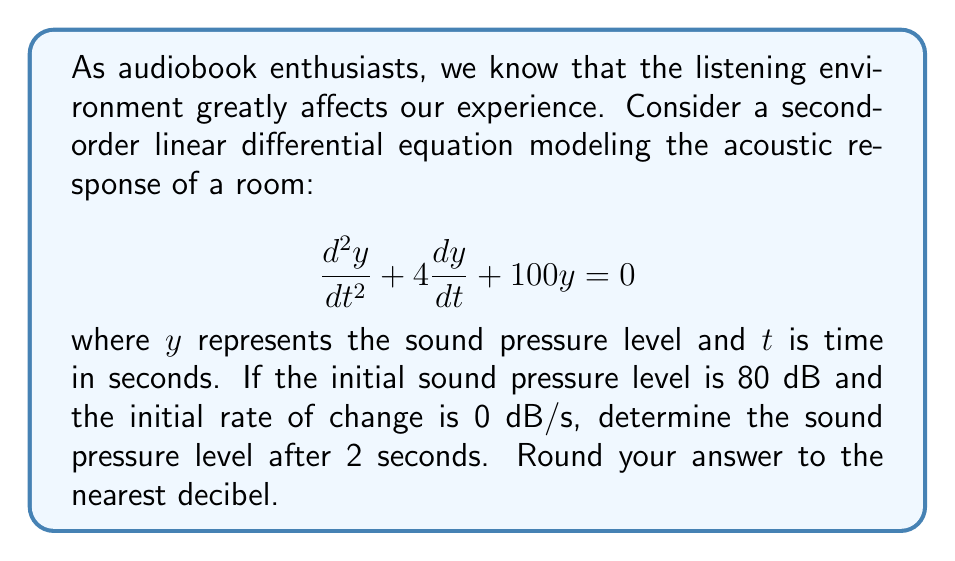Teach me how to tackle this problem. To solve this problem, we'll follow these steps:

1) The general solution for this second-order linear differential equation is:

   $$y(t) = e^{-2t}(A\cos(8t) + B\sin(8t))$$

   where $A$ and $B$ are constants we need to determine.

2) We're given two initial conditions:
   - $y(0) = 80$ (initial sound pressure level)
   - $y'(0) = 0$ (initial rate of change)

3) Using the first condition:
   $$80 = y(0) = e^{-2(0)}(A\cos(0) + B\sin(0)) = A$$

4) For the second condition, we first find $y'(t)$:
   $$y'(t) = -2e^{-2t}(A\cos(8t) + B\sin(8t)) + e^{-2t}(-8A\sin(8t) + 8B\cos(8t))$$

   At $t=0$:
   $$0 = y'(0) = -2A + 8B$$
   $$2A = 8B$$
   $$B = \frac{A}{4} = \frac{80}{4} = 20$$

5) Now we have our complete solution:
   $$y(t) = e^{-2t}(80\cos(8t) + 20\sin(8t))$$

6) To find the sound pressure level after 2 seconds, we evaluate $y(2)$:
   $$y(2) = e^{-2(2)}(80\cos(16) + 20\sin(16))$$
   $$= e^{-4}(80(-0.2879) + 20(0.9577))$$
   $$= 0.0183(-23.032 + 19.154)$$
   $$= 0.0183(-3.878)$$
   $$= -0.0710$$

7) Since sound pressure level is typically expressed in positive decibels, we take the absolute value and round to the nearest integer:

   $|-0.0710| \approx 0.0710$ dB, which rounds to 0 dB.
Answer: 0 dB 